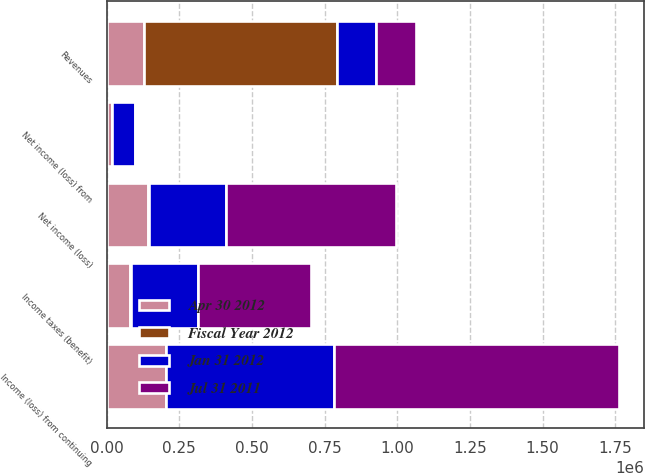<chart> <loc_0><loc_0><loc_500><loc_500><stacked_bar_chart><ecel><fcel>Revenues<fcel>Income (loss) from continuing<fcel>Income taxes (benefit)<fcel>Net income (loss) from<fcel>Net income (loss)<nl><fcel>Jan 31 2012<fcel>135459<fcel>576070<fcel>230102<fcel>80036<fcel>265932<nl><fcel>Jul 31 2011<fcel>135459<fcel>981626<fcel>389923<fcel>5600<fcel>586103<nl><fcel>Fiscal Year 2012<fcel>663280<fcel>1026<fcel>2541<fcel>218<fcel>3349<nl><fcel>Apr 30 2012<fcel>129194<fcel>203929<fcel>80916<fcel>18711<fcel>141724<nl></chart> 